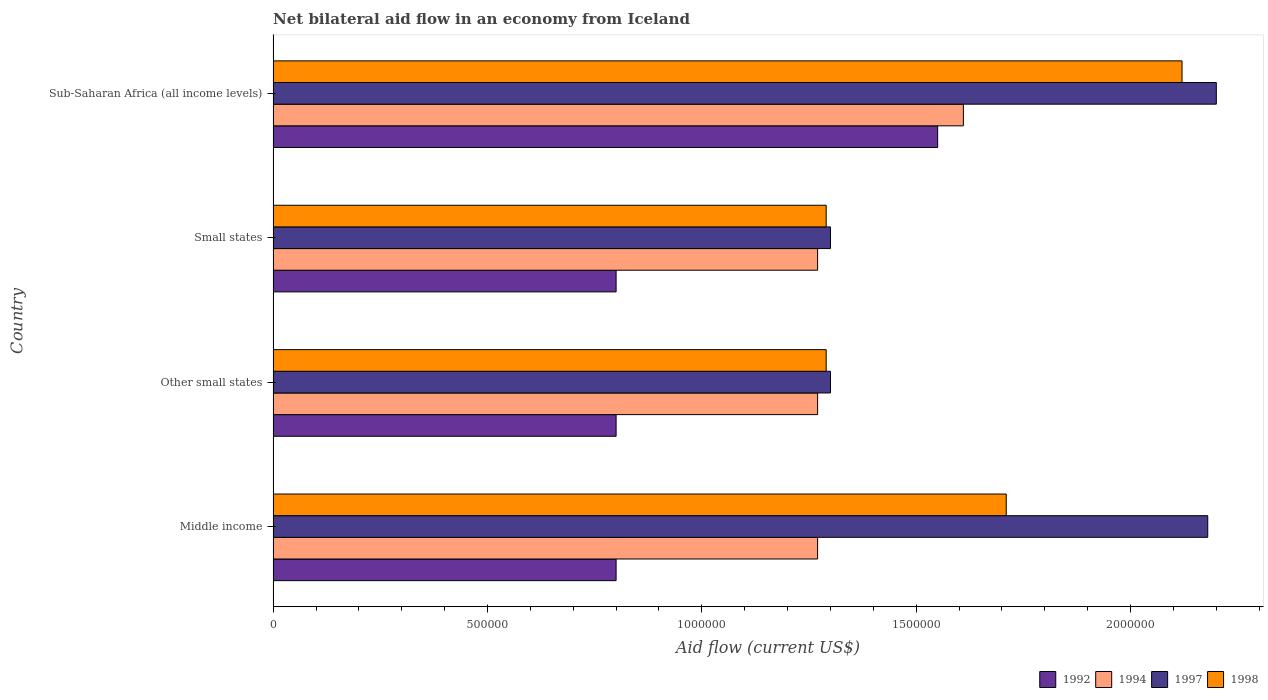How many different coloured bars are there?
Provide a short and direct response. 4. Are the number of bars per tick equal to the number of legend labels?
Keep it short and to the point. Yes. How many bars are there on the 1st tick from the top?
Ensure brevity in your answer.  4. How many bars are there on the 4th tick from the bottom?
Give a very brief answer. 4. What is the label of the 3rd group of bars from the top?
Give a very brief answer. Other small states. In how many cases, is the number of bars for a given country not equal to the number of legend labels?
Your answer should be compact. 0. Across all countries, what is the maximum net bilateral aid flow in 1992?
Your answer should be very brief. 1.55e+06. Across all countries, what is the minimum net bilateral aid flow in 1994?
Offer a very short reply. 1.27e+06. In which country was the net bilateral aid flow in 1992 maximum?
Offer a terse response. Sub-Saharan Africa (all income levels). What is the total net bilateral aid flow in 1994 in the graph?
Your answer should be compact. 5.42e+06. What is the difference between the net bilateral aid flow in 1997 in Sub-Saharan Africa (all income levels) and the net bilateral aid flow in 1994 in Small states?
Your answer should be compact. 9.30e+05. What is the average net bilateral aid flow in 1998 per country?
Offer a terse response. 1.60e+06. What is the difference between the net bilateral aid flow in 1994 and net bilateral aid flow in 1997 in Other small states?
Your answer should be compact. -3.00e+04. What is the ratio of the net bilateral aid flow in 1998 in Other small states to that in Small states?
Offer a terse response. 1. Is the net bilateral aid flow in 1998 in Other small states less than that in Sub-Saharan Africa (all income levels)?
Ensure brevity in your answer.  Yes. What is the difference between the highest and the second highest net bilateral aid flow in 1992?
Make the answer very short. 7.50e+05. What is the difference between the highest and the lowest net bilateral aid flow in 1992?
Provide a short and direct response. 7.50e+05. In how many countries, is the net bilateral aid flow in 1997 greater than the average net bilateral aid flow in 1997 taken over all countries?
Your response must be concise. 2. Is the sum of the net bilateral aid flow in 1994 in Middle income and Small states greater than the maximum net bilateral aid flow in 1997 across all countries?
Make the answer very short. Yes. Is it the case that in every country, the sum of the net bilateral aid flow in 1994 and net bilateral aid flow in 1997 is greater than the net bilateral aid flow in 1992?
Your answer should be compact. Yes. Are the values on the major ticks of X-axis written in scientific E-notation?
Your answer should be compact. No. Where does the legend appear in the graph?
Provide a succinct answer. Bottom right. What is the title of the graph?
Provide a short and direct response. Net bilateral aid flow in an economy from Iceland. Does "2012" appear as one of the legend labels in the graph?
Ensure brevity in your answer.  No. What is the label or title of the Y-axis?
Your response must be concise. Country. What is the Aid flow (current US$) in 1992 in Middle income?
Your answer should be very brief. 8.00e+05. What is the Aid flow (current US$) in 1994 in Middle income?
Make the answer very short. 1.27e+06. What is the Aid flow (current US$) in 1997 in Middle income?
Offer a very short reply. 2.18e+06. What is the Aid flow (current US$) in 1998 in Middle income?
Make the answer very short. 1.71e+06. What is the Aid flow (current US$) in 1994 in Other small states?
Give a very brief answer. 1.27e+06. What is the Aid flow (current US$) in 1997 in Other small states?
Your answer should be very brief. 1.30e+06. What is the Aid flow (current US$) in 1998 in Other small states?
Give a very brief answer. 1.29e+06. What is the Aid flow (current US$) of 1994 in Small states?
Ensure brevity in your answer.  1.27e+06. What is the Aid flow (current US$) of 1997 in Small states?
Give a very brief answer. 1.30e+06. What is the Aid flow (current US$) in 1998 in Small states?
Make the answer very short. 1.29e+06. What is the Aid flow (current US$) of 1992 in Sub-Saharan Africa (all income levels)?
Your answer should be very brief. 1.55e+06. What is the Aid flow (current US$) of 1994 in Sub-Saharan Africa (all income levels)?
Provide a succinct answer. 1.61e+06. What is the Aid flow (current US$) of 1997 in Sub-Saharan Africa (all income levels)?
Keep it short and to the point. 2.20e+06. What is the Aid flow (current US$) of 1998 in Sub-Saharan Africa (all income levels)?
Your answer should be compact. 2.12e+06. Across all countries, what is the maximum Aid flow (current US$) in 1992?
Provide a succinct answer. 1.55e+06. Across all countries, what is the maximum Aid flow (current US$) of 1994?
Provide a succinct answer. 1.61e+06. Across all countries, what is the maximum Aid flow (current US$) of 1997?
Keep it short and to the point. 2.20e+06. Across all countries, what is the maximum Aid flow (current US$) in 1998?
Keep it short and to the point. 2.12e+06. Across all countries, what is the minimum Aid flow (current US$) of 1992?
Ensure brevity in your answer.  8.00e+05. Across all countries, what is the minimum Aid flow (current US$) of 1994?
Give a very brief answer. 1.27e+06. Across all countries, what is the minimum Aid flow (current US$) of 1997?
Make the answer very short. 1.30e+06. Across all countries, what is the minimum Aid flow (current US$) of 1998?
Provide a short and direct response. 1.29e+06. What is the total Aid flow (current US$) in 1992 in the graph?
Offer a very short reply. 3.95e+06. What is the total Aid flow (current US$) of 1994 in the graph?
Your answer should be compact. 5.42e+06. What is the total Aid flow (current US$) of 1997 in the graph?
Your answer should be compact. 6.98e+06. What is the total Aid flow (current US$) of 1998 in the graph?
Provide a short and direct response. 6.41e+06. What is the difference between the Aid flow (current US$) of 1994 in Middle income and that in Other small states?
Make the answer very short. 0. What is the difference between the Aid flow (current US$) of 1997 in Middle income and that in Other small states?
Offer a very short reply. 8.80e+05. What is the difference between the Aid flow (current US$) in 1998 in Middle income and that in Other small states?
Ensure brevity in your answer.  4.20e+05. What is the difference between the Aid flow (current US$) of 1994 in Middle income and that in Small states?
Provide a succinct answer. 0. What is the difference between the Aid flow (current US$) in 1997 in Middle income and that in Small states?
Your response must be concise. 8.80e+05. What is the difference between the Aid flow (current US$) in 1992 in Middle income and that in Sub-Saharan Africa (all income levels)?
Offer a terse response. -7.50e+05. What is the difference between the Aid flow (current US$) in 1994 in Middle income and that in Sub-Saharan Africa (all income levels)?
Your answer should be very brief. -3.40e+05. What is the difference between the Aid flow (current US$) of 1998 in Middle income and that in Sub-Saharan Africa (all income levels)?
Give a very brief answer. -4.10e+05. What is the difference between the Aid flow (current US$) of 1994 in Other small states and that in Small states?
Offer a terse response. 0. What is the difference between the Aid flow (current US$) in 1998 in Other small states and that in Small states?
Keep it short and to the point. 0. What is the difference between the Aid flow (current US$) of 1992 in Other small states and that in Sub-Saharan Africa (all income levels)?
Keep it short and to the point. -7.50e+05. What is the difference between the Aid flow (current US$) in 1997 in Other small states and that in Sub-Saharan Africa (all income levels)?
Your response must be concise. -9.00e+05. What is the difference between the Aid flow (current US$) in 1998 in Other small states and that in Sub-Saharan Africa (all income levels)?
Keep it short and to the point. -8.30e+05. What is the difference between the Aid flow (current US$) in 1992 in Small states and that in Sub-Saharan Africa (all income levels)?
Your response must be concise. -7.50e+05. What is the difference between the Aid flow (current US$) of 1997 in Small states and that in Sub-Saharan Africa (all income levels)?
Offer a very short reply. -9.00e+05. What is the difference between the Aid flow (current US$) in 1998 in Small states and that in Sub-Saharan Africa (all income levels)?
Offer a terse response. -8.30e+05. What is the difference between the Aid flow (current US$) in 1992 in Middle income and the Aid flow (current US$) in 1994 in Other small states?
Make the answer very short. -4.70e+05. What is the difference between the Aid flow (current US$) in 1992 in Middle income and the Aid flow (current US$) in 1997 in Other small states?
Provide a short and direct response. -5.00e+05. What is the difference between the Aid flow (current US$) in 1992 in Middle income and the Aid flow (current US$) in 1998 in Other small states?
Provide a succinct answer. -4.90e+05. What is the difference between the Aid flow (current US$) in 1994 in Middle income and the Aid flow (current US$) in 1997 in Other small states?
Your answer should be very brief. -3.00e+04. What is the difference between the Aid flow (current US$) in 1997 in Middle income and the Aid flow (current US$) in 1998 in Other small states?
Your response must be concise. 8.90e+05. What is the difference between the Aid flow (current US$) in 1992 in Middle income and the Aid flow (current US$) in 1994 in Small states?
Your response must be concise. -4.70e+05. What is the difference between the Aid flow (current US$) of 1992 in Middle income and the Aid flow (current US$) of 1997 in Small states?
Give a very brief answer. -5.00e+05. What is the difference between the Aid flow (current US$) in 1992 in Middle income and the Aid flow (current US$) in 1998 in Small states?
Offer a very short reply. -4.90e+05. What is the difference between the Aid flow (current US$) of 1994 in Middle income and the Aid flow (current US$) of 1998 in Small states?
Ensure brevity in your answer.  -2.00e+04. What is the difference between the Aid flow (current US$) in 1997 in Middle income and the Aid flow (current US$) in 1998 in Small states?
Keep it short and to the point. 8.90e+05. What is the difference between the Aid flow (current US$) of 1992 in Middle income and the Aid flow (current US$) of 1994 in Sub-Saharan Africa (all income levels)?
Provide a short and direct response. -8.10e+05. What is the difference between the Aid flow (current US$) of 1992 in Middle income and the Aid flow (current US$) of 1997 in Sub-Saharan Africa (all income levels)?
Your response must be concise. -1.40e+06. What is the difference between the Aid flow (current US$) in 1992 in Middle income and the Aid flow (current US$) in 1998 in Sub-Saharan Africa (all income levels)?
Make the answer very short. -1.32e+06. What is the difference between the Aid flow (current US$) of 1994 in Middle income and the Aid flow (current US$) of 1997 in Sub-Saharan Africa (all income levels)?
Provide a short and direct response. -9.30e+05. What is the difference between the Aid flow (current US$) in 1994 in Middle income and the Aid flow (current US$) in 1998 in Sub-Saharan Africa (all income levels)?
Ensure brevity in your answer.  -8.50e+05. What is the difference between the Aid flow (current US$) in 1992 in Other small states and the Aid flow (current US$) in 1994 in Small states?
Your answer should be very brief. -4.70e+05. What is the difference between the Aid flow (current US$) in 1992 in Other small states and the Aid flow (current US$) in 1997 in Small states?
Keep it short and to the point. -5.00e+05. What is the difference between the Aid flow (current US$) of 1992 in Other small states and the Aid flow (current US$) of 1998 in Small states?
Your answer should be very brief. -4.90e+05. What is the difference between the Aid flow (current US$) in 1994 in Other small states and the Aid flow (current US$) in 1997 in Small states?
Ensure brevity in your answer.  -3.00e+04. What is the difference between the Aid flow (current US$) in 1994 in Other small states and the Aid flow (current US$) in 1998 in Small states?
Make the answer very short. -2.00e+04. What is the difference between the Aid flow (current US$) of 1992 in Other small states and the Aid flow (current US$) of 1994 in Sub-Saharan Africa (all income levels)?
Offer a very short reply. -8.10e+05. What is the difference between the Aid flow (current US$) in 1992 in Other small states and the Aid flow (current US$) in 1997 in Sub-Saharan Africa (all income levels)?
Your response must be concise. -1.40e+06. What is the difference between the Aid flow (current US$) of 1992 in Other small states and the Aid flow (current US$) of 1998 in Sub-Saharan Africa (all income levels)?
Offer a terse response. -1.32e+06. What is the difference between the Aid flow (current US$) in 1994 in Other small states and the Aid flow (current US$) in 1997 in Sub-Saharan Africa (all income levels)?
Offer a terse response. -9.30e+05. What is the difference between the Aid flow (current US$) in 1994 in Other small states and the Aid flow (current US$) in 1998 in Sub-Saharan Africa (all income levels)?
Provide a succinct answer. -8.50e+05. What is the difference between the Aid flow (current US$) of 1997 in Other small states and the Aid flow (current US$) of 1998 in Sub-Saharan Africa (all income levels)?
Your response must be concise. -8.20e+05. What is the difference between the Aid flow (current US$) of 1992 in Small states and the Aid flow (current US$) of 1994 in Sub-Saharan Africa (all income levels)?
Your response must be concise. -8.10e+05. What is the difference between the Aid flow (current US$) of 1992 in Small states and the Aid flow (current US$) of 1997 in Sub-Saharan Africa (all income levels)?
Your answer should be very brief. -1.40e+06. What is the difference between the Aid flow (current US$) of 1992 in Small states and the Aid flow (current US$) of 1998 in Sub-Saharan Africa (all income levels)?
Your answer should be very brief. -1.32e+06. What is the difference between the Aid flow (current US$) of 1994 in Small states and the Aid flow (current US$) of 1997 in Sub-Saharan Africa (all income levels)?
Your answer should be compact. -9.30e+05. What is the difference between the Aid flow (current US$) in 1994 in Small states and the Aid flow (current US$) in 1998 in Sub-Saharan Africa (all income levels)?
Offer a terse response. -8.50e+05. What is the difference between the Aid flow (current US$) of 1997 in Small states and the Aid flow (current US$) of 1998 in Sub-Saharan Africa (all income levels)?
Offer a very short reply. -8.20e+05. What is the average Aid flow (current US$) in 1992 per country?
Provide a succinct answer. 9.88e+05. What is the average Aid flow (current US$) in 1994 per country?
Make the answer very short. 1.36e+06. What is the average Aid flow (current US$) of 1997 per country?
Your response must be concise. 1.74e+06. What is the average Aid flow (current US$) in 1998 per country?
Offer a terse response. 1.60e+06. What is the difference between the Aid flow (current US$) in 1992 and Aid flow (current US$) in 1994 in Middle income?
Make the answer very short. -4.70e+05. What is the difference between the Aid flow (current US$) in 1992 and Aid flow (current US$) in 1997 in Middle income?
Ensure brevity in your answer.  -1.38e+06. What is the difference between the Aid flow (current US$) in 1992 and Aid flow (current US$) in 1998 in Middle income?
Keep it short and to the point. -9.10e+05. What is the difference between the Aid flow (current US$) of 1994 and Aid flow (current US$) of 1997 in Middle income?
Offer a very short reply. -9.10e+05. What is the difference between the Aid flow (current US$) in 1994 and Aid flow (current US$) in 1998 in Middle income?
Your response must be concise. -4.40e+05. What is the difference between the Aid flow (current US$) of 1997 and Aid flow (current US$) of 1998 in Middle income?
Offer a terse response. 4.70e+05. What is the difference between the Aid flow (current US$) in 1992 and Aid flow (current US$) in 1994 in Other small states?
Ensure brevity in your answer.  -4.70e+05. What is the difference between the Aid flow (current US$) in 1992 and Aid flow (current US$) in 1997 in Other small states?
Give a very brief answer. -5.00e+05. What is the difference between the Aid flow (current US$) of 1992 and Aid flow (current US$) of 1998 in Other small states?
Make the answer very short. -4.90e+05. What is the difference between the Aid flow (current US$) in 1994 and Aid flow (current US$) in 1997 in Other small states?
Your answer should be compact. -3.00e+04. What is the difference between the Aid flow (current US$) in 1994 and Aid flow (current US$) in 1998 in Other small states?
Your response must be concise. -2.00e+04. What is the difference between the Aid flow (current US$) in 1992 and Aid flow (current US$) in 1994 in Small states?
Your response must be concise. -4.70e+05. What is the difference between the Aid flow (current US$) in 1992 and Aid flow (current US$) in 1997 in Small states?
Keep it short and to the point. -5.00e+05. What is the difference between the Aid flow (current US$) in 1992 and Aid flow (current US$) in 1998 in Small states?
Make the answer very short. -4.90e+05. What is the difference between the Aid flow (current US$) of 1994 and Aid flow (current US$) of 1997 in Small states?
Give a very brief answer. -3.00e+04. What is the difference between the Aid flow (current US$) in 1992 and Aid flow (current US$) in 1994 in Sub-Saharan Africa (all income levels)?
Your response must be concise. -6.00e+04. What is the difference between the Aid flow (current US$) in 1992 and Aid flow (current US$) in 1997 in Sub-Saharan Africa (all income levels)?
Give a very brief answer. -6.50e+05. What is the difference between the Aid flow (current US$) of 1992 and Aid flow (current US$) of 1998 in Sub-Saharan Africa (all income levels)?
Offer a very short reply. -5.70e+05. What is the difference between the Aid flow (current US$) of 1994 and Aid flow (current US$) of 1997 in Sub-Saharan Africa (all income levels)?
Your response must be concise. -5.90e+05. What is the difference between the Aid flow (current US$) in 1994 and Aid flow (current US$) in 1998 in Sub-Saharan Africa (all income levels)?
Offer a very short reply. -5.10e+05. What is the ratio of the Aid flow (current US$) of 1997 in Middle income to that in Other small states?
Provide a succinct answer. 1.68. What is the ratio of the Aid flow (current US$) in 1998 in Middle income to that in Other small states?
Your response must be concise. 1.33. What is the ratio of the Aid flow (current US$) of 1992 in Middle income to that in Small states?
Give a very brief answer. 1. What is the ratio of the Aid flow (current US$) of 1997 in Middle income to that in Small states?
Make the answer very short. 1.68. What is the ratio of the Aid flow (current US$) in 1998 in Middle income to that in Small states?
Your answer should be compact. 1.33. What is the ratio of the Aid flow (current US$) of 1992 in Middle income to that in Sub-Saharan Africa (all income levels)?
Ensure brevity in your answer.  0.52. What is the ratio of the Aid flow (current US$) of 1994 in Middle income to that in Sub-Saharan Africa (all income levels)?
Provide a succinct answer. 0.79. What is the ratio of the Aid flow (current US$) of 1997 in Middle income to that in Sub-Saharan Africa (all income levels)?
Ensure brevity in your answer.  0.99. What is the ratio of the Aid flow (current US$) of 1998 in Middle income to that in Sub-Saharan Africa (all income levels)?
Give a very brief answer. 0.81. What is the ratio of the Aid flow (current US$) of 1994 in Other small states to that in Small states?
Offer a terse response. 1. What is the ratio of the Aid flow (current US$) in 1997 in Other small states to that in Small states?
Your answer should be compact. 1. What is the ratio of the Aid flow (current US$) in 1992 in Other small states to that in Sub-Saharan Africa (all income levels)?
Your answer should be very brief. 0.52. What is the ratio of the Aid flow (current US$) of 1994 in Other small states to that in Sub-Saharan Africa (all income levels)?
Give a very brief answer. 0.79. What is the ratio of the Aid flow (current US$) of 1997 in Other small states to that in Sub-Saharan Africa (all income levels)?
Ensure brevity in your answer.  0.59. What is the ratio of the Aid flow (current US$) of 1998 in Other small states to that in Sub-Saharan Africa (all income levels)?
Your response must be concise. 0.61. What is the ratio of the Aid flow (current US$) of 1992 in Small states to that in Sub-Saharan Africa (all income levels)?
Your response must be concise. 0.52. What is the ratio of the Aid flow (current US$) of 1994 in Small states to that in Sub-Saharan Africa (all income levels)?
Offer a terse response. 0.79. What is the ratio of the Aid flow (current US$) of 1997 in Small states to that in Sub-Saharan Africa (all income levels)?
Your answer should be compact. 0.59. What is the ratio of the Aid flow (current US$) in 1998 in Small states to that in Sub-Saharan Africa (all income levels)?
Your response must be concise. 0.61. What is the difference between the highest and the second highest Aid flow (current US$) in 1992?
Offer a very short reply. 7.50e+05. What is the difference between the highest and the second highest Aid flow (current US$) of 1994?
Give a very brief answer. 3.40e+05. What is the difference between the highest and the second highest Aid flow (current US$) of 1997?
Provide a succinct answer. 2.00e+04. What is the difference between the highest and the lowest Aid flow (current US$) in 1992?
Keep it short and to the point. 7.50e+05. What is the difference between the highest and the lowest Aid flow (current US$) of 1994?
Your answer should be compact. 3.40e+05. What is the difference between the highest and the lowest Aid flow (current US$) of 1997?
Offer a terse response. 9.00e+05. What is the difference between the highest and the lowest Aid flow (current US$) of 1998?
Give a very brief answer. 8.30e+05. 